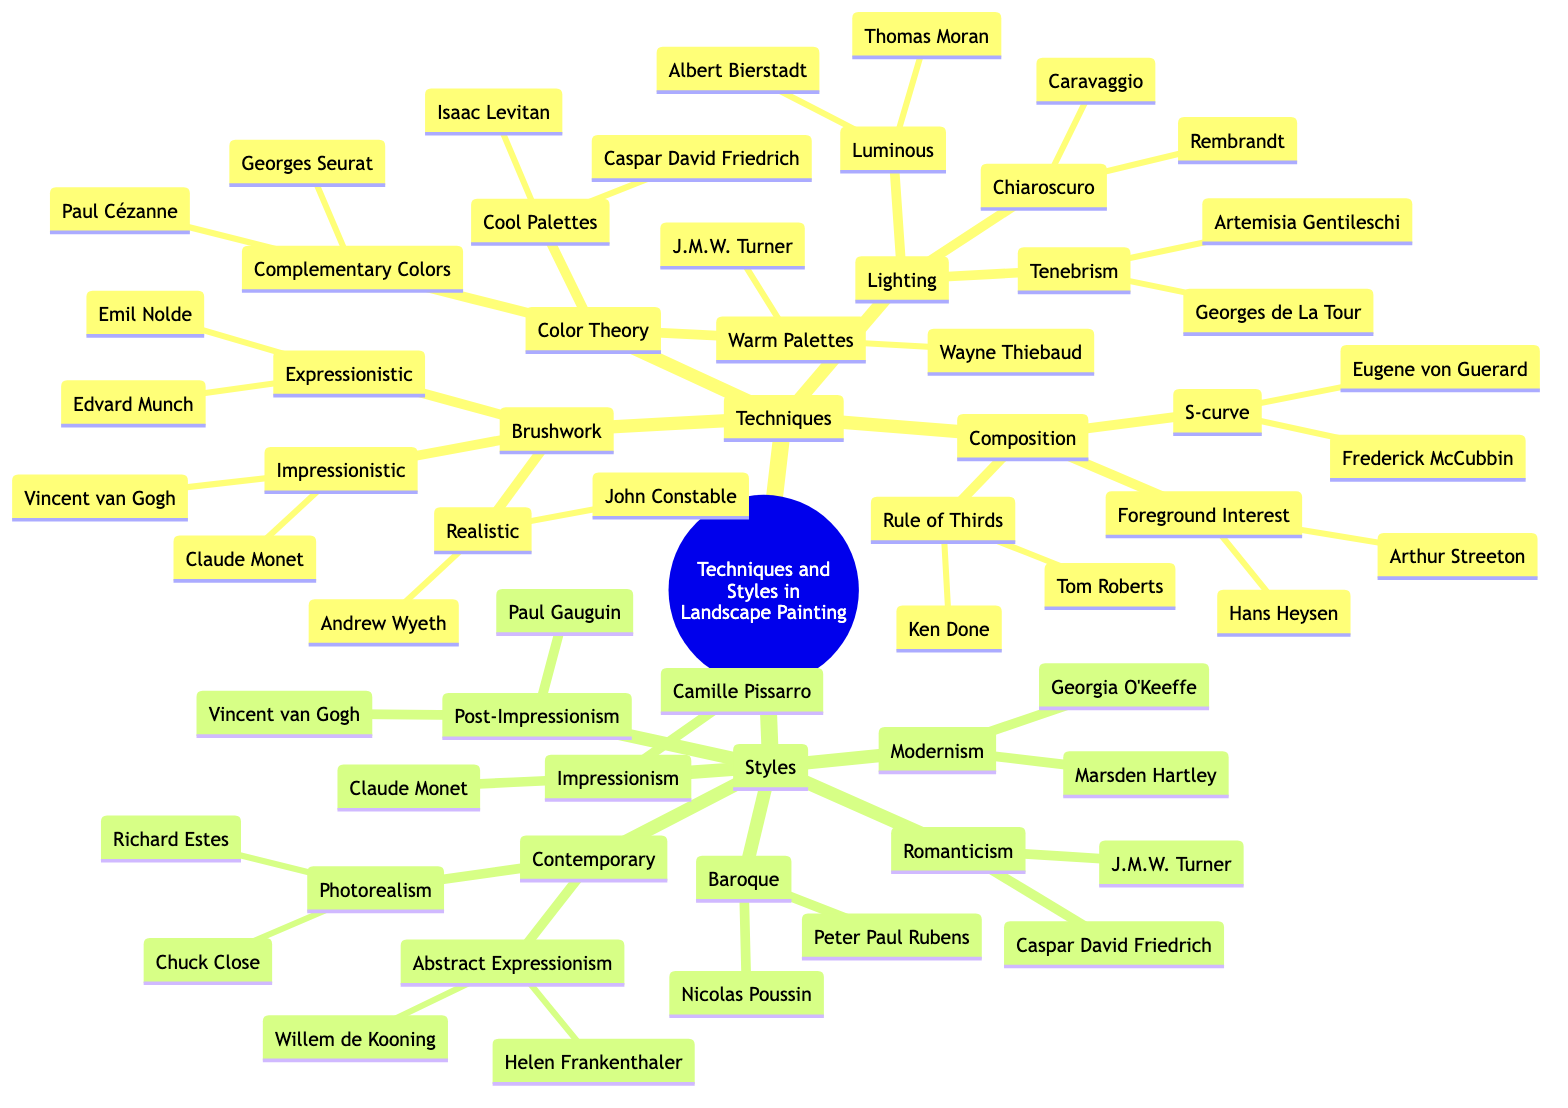What is one of the techniques listed in the diagram? The diagram classifies techniques into categories such as Brushwork, Color Theory, Lighting, and Composition. A single technique from any of these categories counts as an answer. For example, "Brushwork" is one of these techniques.
Answer: Brushwork How many artists are listed under the Impressionistic brushwork technique? Under the Impressionistic category of Brushwork, there are two listed artists: Claude Monet and Vincent van Gogh. This requires counting the artists' names presented in that specific section of the mind map.
Answer: 2 Which style features artists Caspar David Friedrich and J.M.W. Turner? The style category contains various styles; Caspar David Friedrich and J.M.W. Turner are associated with the Romanticism style. By examining the list of styles and matching the artists to their respective style, we find the answer.
Answer: Romanticism What is the main theme connecting Chiaroscuro and Tenebrism in the lighting techniques? Both Chiaroscuro and Tenebrism deal with light and shadow in painting. A deeper look into the Lighting section reveals that these two techniques utilize contrasting light effects, which is their common theme.
Answer: Light and shadow Which technique includes the use of Cool Palettes? The Color Theory section contains Warm Palettes, Cool Palettes, and Complementary Colors, indicating that Cool Palettes is a specific technique that falls under Color Theory. The question asks for the connection between techniques and their categories.
Answer: Color Theory How many total types of brushwork techniques are listed? The Brushwork category presents three different types of techniques: Impressionistic, Realistic, and Expressionistic. To answer the question, we simply count these distinct types within the Brushwork section.
Answer: 3 What are the two subcategories under Contemporary styles? Under the Contemporary category, there are two distinct styles listed: Photorealism and Abstract Expressionism. By reviewing the diagram, we can discern these as the subcategories of Contemporary style.
Answer: Photorealism and Abstract Expressionism Who is a key artist associated with the use of Complementary Colors? Georges Seurat and Paul Cézanne are noted under the Complementary Colors technique in the Color Theory section. Since the question specifies a key artist, we can mention one at a time.
Answer: Georges Seurat Which artist is known for their use of the Rule of Thirds? Under the Composition section, Ken Done and Tom Roberts are noted for their use of the Rule of Thirds technique, and either artist would answer this question.
Answer: Ken Done 